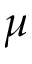<formula> <loc_0><loc_0><loc_500><loc_500>\mu</formula> 